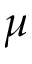<formula> <loc_0><loc_0><loc_500><loc_500>\mu</formula> 